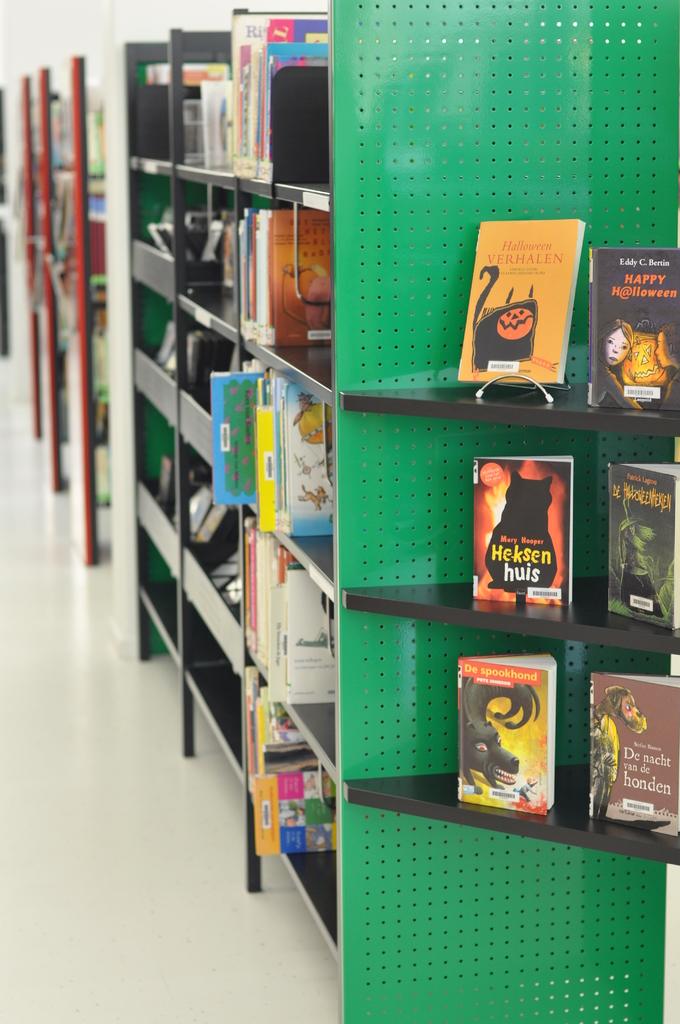What's the title of the first book in the second row?
Give a very brief answer. Heksen huis. Who is the author of happy halloween?
Provide a succinct answer. Eddy c bertin. 